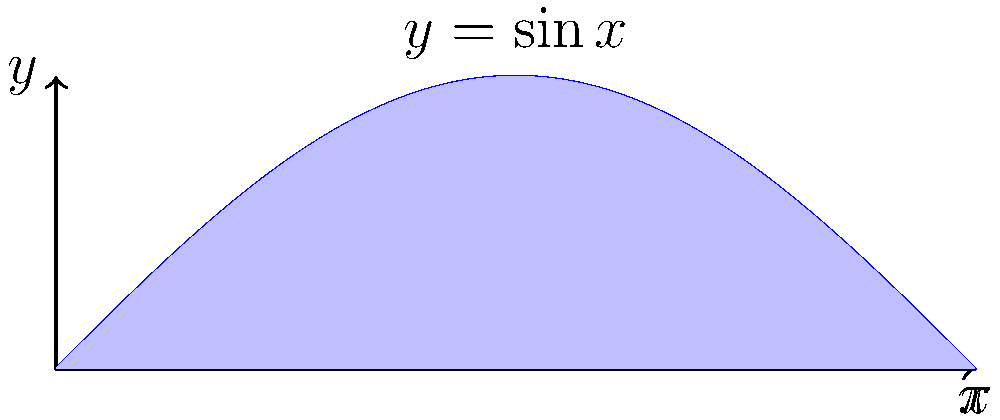Dr. Ernest Yee Chung Lee often emphasized the importance of visualizing mathematical concepts. Consider the area under the curve $y = \sin x$ from $x = 0$ to $x = \pi$, as shown in the figure. Calculate this area using integration. Let's approach this step-by-step, as Dr. Lee would have encouraged:

1) The area under the curve is given by the definite integral:

   $$A = \int_0^\pi \sin x \, dx$$

2) To solve this, we need to recall the antiderivative of sine:

   $$\int \sin x \, dx = -\cos x + C$$

3) Now we can apply the Fundamental Theorem of Calculus:

   $$A = [-\cos x]_0^\pi = (-\cos \pi) - (-\cos 0)$$

4) Evaluate:
   - $\cos \pi = -1$
   - $\cos 0 = 1$

   $$A = -(-1) - (-1) = 1 + 1 = 2$$

Therefore, the area under the curve $y = \sin x$ from $x = 0$ to $x = \pi$ is 2 square units.
Answer: 2 square units 